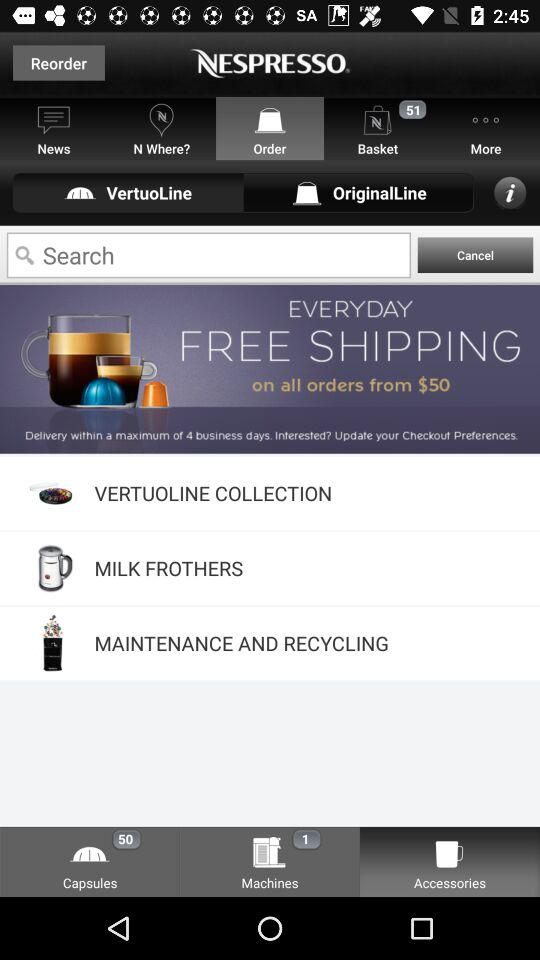How many capsules are shown? There are 50 capsules. 